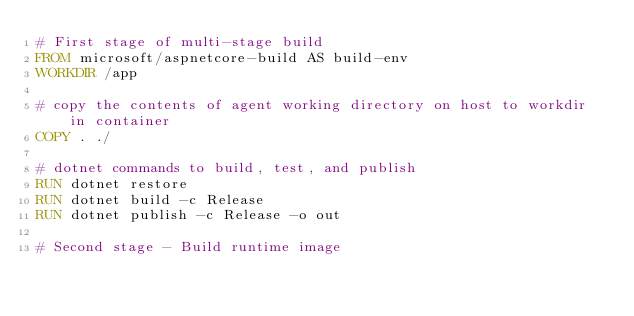<code> <loc_0><loc_0><loc_500><loc_500><_Dockerfile_># First stage of multi-stage build
FROM microsoft/aspnetcore-build AS build-env
WORKDIR /app

# copy the contents of agent working directory on host to workdir in container
COPY . ./

# dotnet commands to build, test, and publish
RUN dotnet restore
RUN dotnet build -c Release
RUN dotnet publish -c Release -o out

# Second stage - Build runtime image</code> 